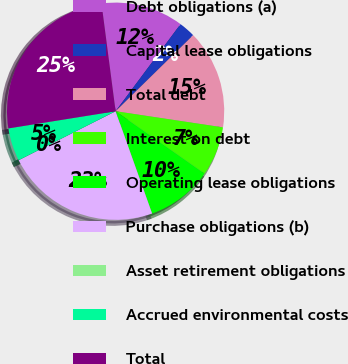Convert chart to OTSL. <chart><loc_0><loc_0><loc_500><loc_500><pie_chart><fcel>Debt obligations (a)<fcel>Capital lease obligations<fcel>Total debt<fcel>Interest on debt<fcel>Operating lease obligations<fcel>Purchase obligations (b)<fcel>Asset retirement obligations<fcel>Accrued environmental costs<fcel>Total<nl><fcel>12.27%<fcel>2.46%<fcel>14.72%<fcel>7.36%<fcel>9.81%<fcel>23.01%<fcel>0.01%<fcel>4.91%<fcel>25.46%<nl></chart> 